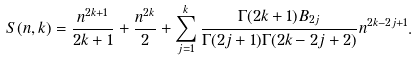<formula> <loc_0><loc_0><loc_500><loc_500>S ( n , k ) = \frac { n ^ { 2 k + 1 } } { 2 k + 1 } + \frac { n ^ { 2 k } } { 2 } + \sum _ { j = 1 } ^ { k } \frac { \Gamma ( 2 k + 1 ) B _ { 2 j } } { \Gamma ( 2 j + 1 ) \Gamma ( 2 k - 2 j + 2 ) } n ^ { 2 k - 2 j + 1 } .</formula> 